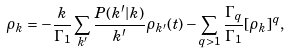<formula> <loc_0><loc_0><loc_500><loc_500>\rho _ { k } = - \frac { k } { \Gamma _ { 1 } } \sum _ { k ^ { \prime } } \frac { P ( k ^ { \prime } | k ) } { k ^ { \prime } } \rho _ { k ^ { \prime } } ( t ) - \sum _ { q > 1 } \frac { \Gamma _ { q } } { \Gamma _ { 1 } } [ \rho _ { k } ] ^ { q } ,</formula> 